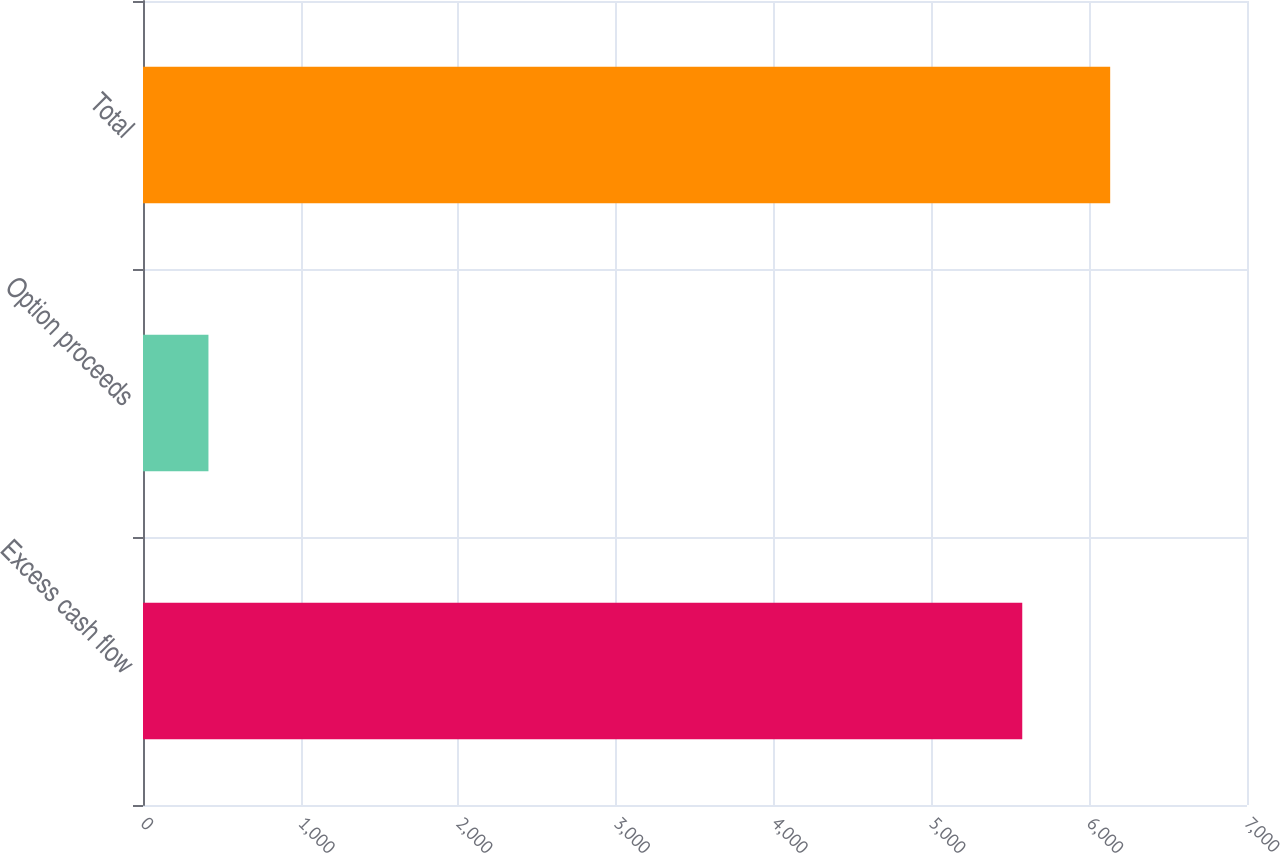<chart> <loc_0><loc_0><loc_500><loc_500><bar_chart><fcel>Excess cash flow<fcel>Option proceeds<fcel>Total<nl><fcel>5575<fcel>415<fcel>6132.5<nl></chart> 